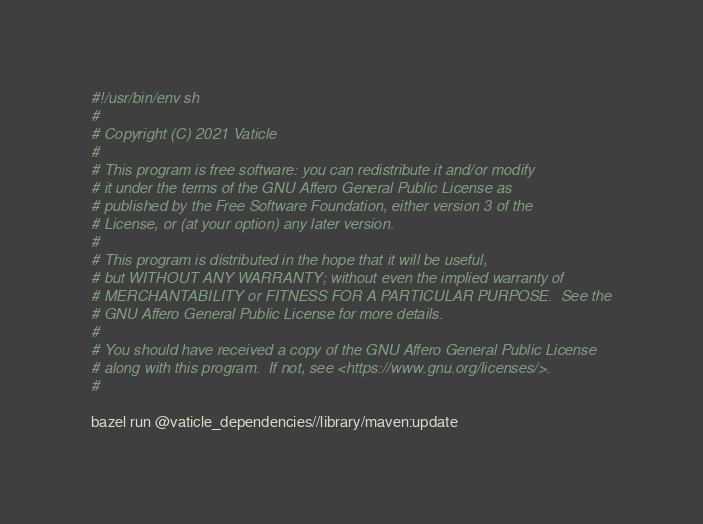<code> <loc_0><loc_0><loc_500><loc_500><_Bash_>#!/usr/bin/env sh
#
# Copyright (C) 2021 Vaticle
#
# This program is free software: you can redistribute it and/or modify
# it under the terms of the GNU Affero General Public License as
# published by the Free Software Foundation, either version 3 of the
# License, or (at your option) any later version.
#
# This program is distributed in the hope that it will be useful,
# but WITHOUT ANY WARRANTY; without even the implied warranty of
# MERCHANTABILITY or FITNESS FOR A PARTICULAR PURPOSE.  See the
# GNU Affero General Public License for more details.
#
# You should have received a copy of the GNU Affero General Public License
# along with this program.  If not, see <https://www.gnu.org/licenses/>.
#

bazel run @vaticle_dependencies//library/maven:update
</code> 